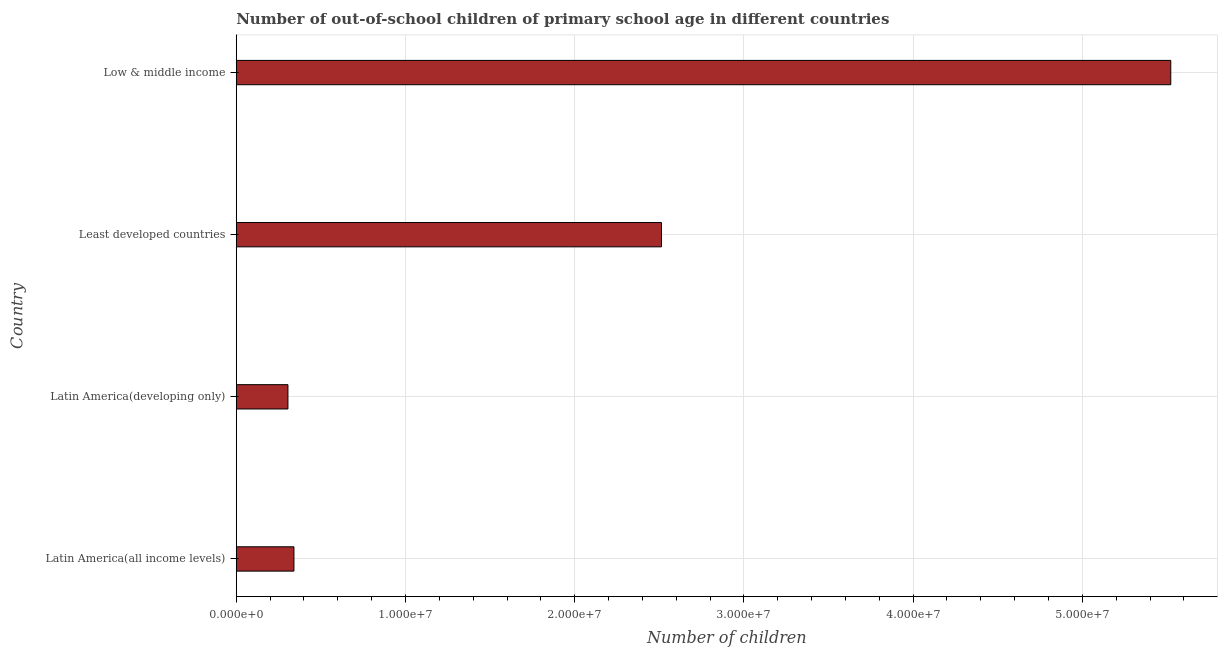Does the graph contain grids?
Your answer should be compact. Yes. What is the title of the graph?
Offer a terse response. Number of out-of-school children of primary school age in different countries. What is the label or title of the X-axis?
Ensure brevity in your answer.  Number of children. What is the label or title of the Y-axis?
Your response must be concise. Country. What is the number of out-of-school children in Least developed countries?
Offer a very short reply. 2.51e+07. Across all countries, what is the maximum number of out-of-school children?
Provide a succinct answer. 5.52e+07. Across all countries, what is the minimum number of out-of-school children?
Your answer should be very brief. 3.05e+06. In which country was the number of out-of-school children maximum?
Keep it short and to the point. Low & middle income. In which country was the number of out-of-school children minimum?
Offer a very short reply. Latin America(developing only). What is the sum of the number of out-of-school children?
Your answer should be very brief. 8.68e+07. What is the difference between the number of out-of-school children in Least developed countries and Low & middle income?
Your response must be concise. -3.01e+07. What is the average number of out-of-school children per country?
Keep it short and to the point. 2.17e+07. What is the median number of out-of-school children?
Make the answer very short. 1.43e+07. In how many countries, is the number of out-of-school children greater than 12000000 ?
Offer a terse response. 2. What is the ratio of the number of out-of-school children in Latin America(developing only) to that in Low & middle income?
Ensure brevity in your answer.  0.06. Is the difference between the number of out-of-school children in Latin America(developing only) and Least developed countries greater than the difference between any two countries?
Your answer should be compact. No. What is the difference between the highest and the second highest number of out-of-school children?
Your response must be concise. 3.01e+07. Is the sum of the number of out-of-school children in Least developed countries and Low & middle income greater than the maximum number of out-of-school children across all countries?
Your answer should be compact. Yes. What is the difference between the highest and the lowest number of out-of-school children?
Ensure brevity in your answer.  5.22e+07. How many bars are there?
Ensure brevity in your answer.  4. What is the difference between two consecutive major ticks on the X-axis?
Your answer should be compact. 1.00e+07. What is the Number of children in Latin America(all income levels)?
Make the answer very short. 3.41e+06. What is the Number of children in Latin America(developing only)?
Keep it short and to the point. 3.05e+06. What is the Number of children in Least developed countries?
Make the answer very short. 2.51e+07. What is the Number of children in Low & middle income?
Your answer should be very brief. 5.52e+07. What is the difference between the Number of children in Latin America(all income levels) and Latin America(developing only)?
Your answer should be very brief. 3.55e+05. What is the difference between the Number of children in Latin America(all income levels) and Least developed countries?
Provide a succinct answer. -2.17e+07. What is the difference between the Number of children in Latin America(all income levels) and Low & middle income?
Make the answer very short. -5.18e+07. What is the difference between the Number of children in Latin America(developing only) and Least developed countries?
Your answer should be compact. -2.21e+07. What is the difference between the Number of children in Latin America(developing only) and Low & middle income?
Ensure brevity in your answer.  -5.22e+07. What is the difference between the Number of children in Least developed countries and Low & middle income?
Give a very brief answer. -3.01e+07. What is the ratio of the Number of children in Latin America(all income levels) to that in Latin America(developing only)?
Your answer should be compact. 1.12. What is the ratio of the Number of children in Latin America(all income levels) to that in Least developed countries?
Make the answer very short. 0.14. What is the ratio of the Number of children in Latin America(all income levels) to that in Low & middle income?
Offer a terse response. 0.06. What is the ratio of the Number of children in Latin America(developing only) to that in Least developed countries?
Your answer should be very brief. 0.12. What is the ratio of the Number of children in Latin America(developing only) to that in Low & middle income?
Your answer should be very brief. 0.06. What is the ratio of the Number of children in Least developed countries to that in Low & middle income?
Ensure brevity in your answer.  0.46. 